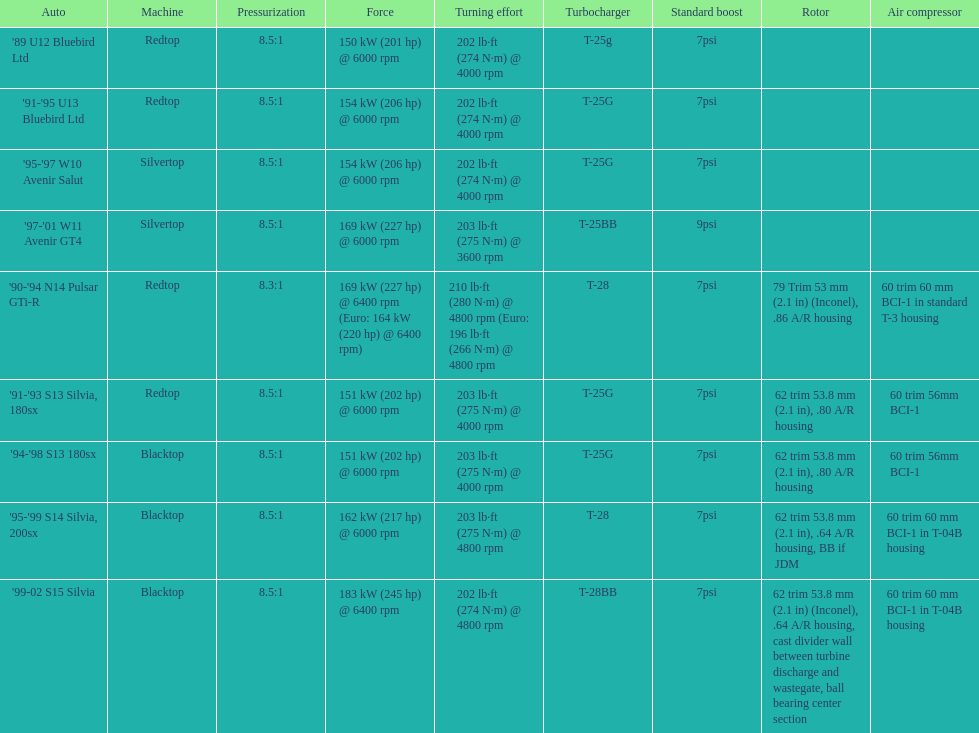Which engines were used after 1999? Silvertop, Blacktop. 